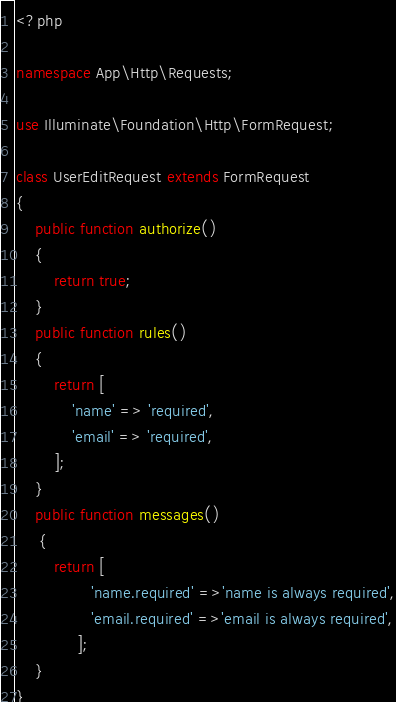Convert code to text. <code><loc_0><loc_0><loc_500><loc_500><_PHP_><?php

namespace App\Http\Requests;

use Illuminate\Foundation\Http\FormRequest;

class UserEditRequest extends FormRequest
{
    public function authorize()
    {
        return true;
    }
    public function rules()
    {
        return [
            'name' => 'required',
            'email' => 'required',
        ];
    }
    public function messages()
     {
        return [
                'name.required' =>'name is always required',
                'email.required' =>'email is always required',
             ];
    }
}
</code> 